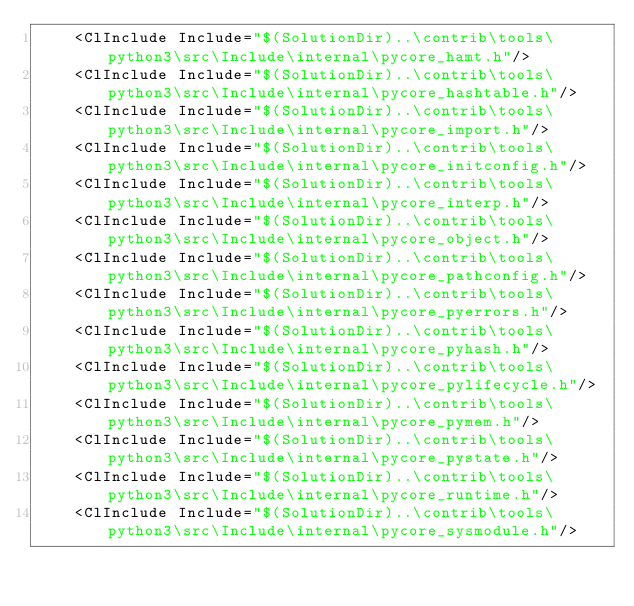<code> <loc_0><loc_0><loc_500><loc_500><_XML_>    <ClInclude Include="$(SolutionDir)..\contrib\tools\python3\src\Include\internal\pycore_hamt.h"/>
    <ClInclude Include="$(SolutionDir)..\contrib\tools\python3\src\Include\internal\pycore_hashtable.h"/>
    <ClInclude Include="$(SolutionDir)..\contrib\tools\python3\src\Include\internal\pycore_import.h"/>
    <ClInclude Include="$(SolutionDir)..\contrib\tools\python3\src\Include\internal\pycore_initconfig.h"/>
    <ClInclude Include="$(SolutionDir)..\contrib\tools\python3\src\Include\internal\pycore_interp.h"/>
    <ClInclude Include="$(SolutionDir)..\contrib\tools\python3\src\Include\internal\pycore_object.h"/>
    <ClInclude Include="$(SolutionDir)..\contrib\tools\python3\src\Include\internal\pycore_pathconfig.h"/>
    <ClInclude Include="$(SolutionDir)..\contrib\tools\python3\src\Include\internal\pycore_pyerrors.h"/>
    <ClInclude Include="$(SolutionDir)..\contrib\tools\python3\src\Include\internal\pycore_pyhash.h"/>
    <ClInclude Include="$(SolutionDir)..\contrib\tools\python3\src\Include\internal\pycore_pylifecycle.h"/>
    <ClInclude Include="$(SolutionDir)..\contrib\tools\python3\src\Include\internal\pycore_pymem.h"/>
    <ClInclude Include="$(SolutionDir)..\contrib\tools\python3\src\Include\internal\pycore_pystate.h"/>
    <ClInclude Include="$(SolutionDir)..\contrib\tools\python3\src\Include\internal\pycore_runtime.h"/>
    <ClInclude Include="$(SolutionDir)..\contrib\tools\python3\src\Include\internal\pycore_sysmodule.h"/></code> 